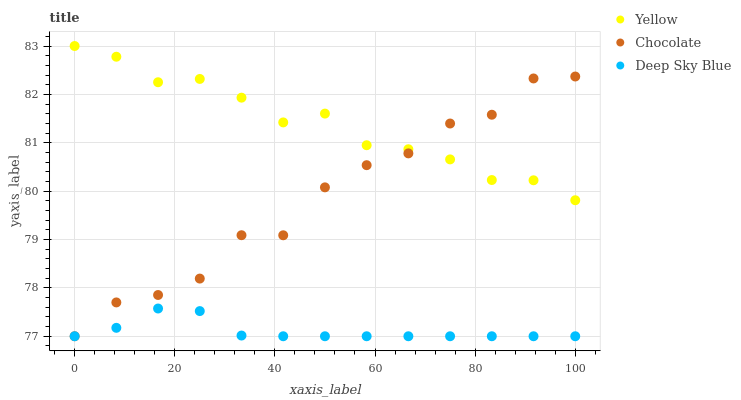Does Deep Sky Blue have the minimum area under the curve?
Answer yes or no. Yes. Does Yellow have the maximum area under the curve?
Answer yes or no. Yes. Does Chocolate have the minimum area under the curve?
Answer yes or no. No. Does Chocolate have the maximum area under the curve?
Answer yes or no. No. Is Deep Sky Blue the smoothest?
Answer yes or no. Yes. Is Chocolate the roughest?
Answer yes or no. Yes. Is Yellow the smoothest?
Answer yes or no. No. Is Yellow the roughest?
Answer yes or no. No. Does Deep Sky Blue have the lowest value?
Answer yes or no. Yes. Does Yellow have the lowest value?
Answer yes or no. No. Does Yellow have the highest value?
Answer yes or no. Yes. Does Chocolate have the highest value?
Answer yes or no. No. Is Deep Sky Blue less than Yellow?
Answer yes or no. Yes. Is Yellow greater than Deep Sky Blue?
Answer yes or no. Yes. Does Deep Sky Blue intersect Chocolate?
Answer yes or no. Yes. Is Deep Sky Blue less than Chocolate?
Answer yes or no. No. Is Deep Sky Blue greater than Chocolate?
Answer yes or no. No. Does Deep Sky Blue intersect Yellow?
Answer yes or no. No. 